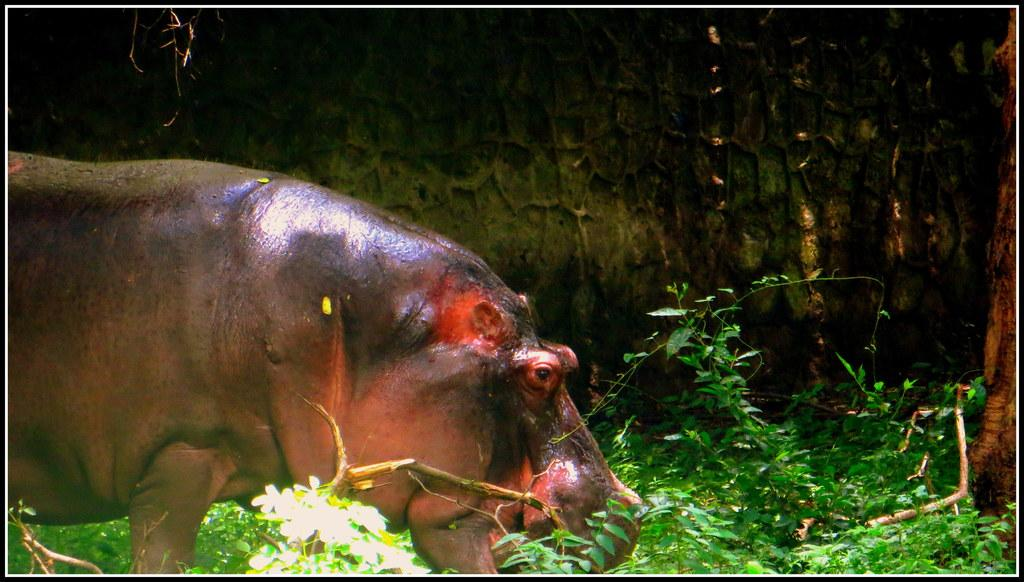What animal is present in the image? There is a hippopotamus in the image. What is the color of the hippopotamus? The hippopotamus is brown in color. What type of vegetation can be seen in the image? There are green color plants on the ground. What can be seen in the background of the image? There is a black color wall in the background. What type of drug is the hippopotamus using in the image? There is no drug present in the image; it features a hippopotamus, green color plants, and a black color wall in the background. 